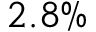Convert formula to latex. <formula><loc_0><loc_0><loc_500><loc_500>2 . 8 \%</formula> 